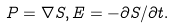Convert formula to latex. <formula><loc_0><loc_0><loc_500><loc_500>P = \nabla S , E = - \partial S / \partial t .</formula> 